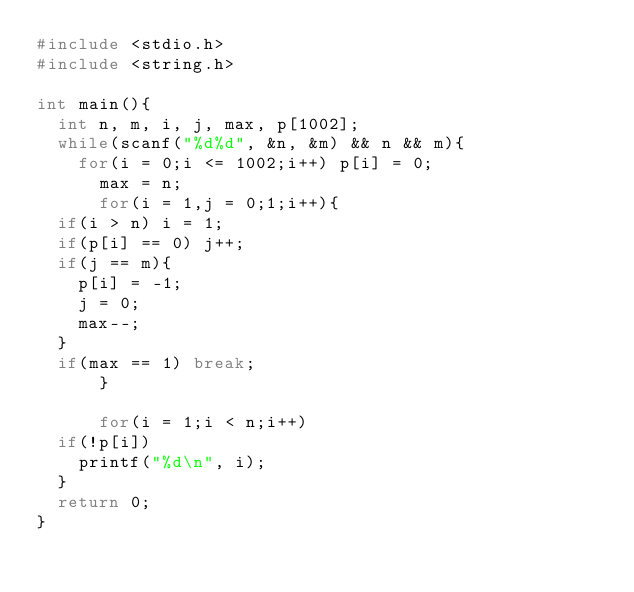<code> <loc_0><loc_0><loc_500><loc_500><_C_>#include <stdio.h>
#include <string.h>

int main(){
  int n, m, i, j, max, p[1002];
  while(scanf("%d%d", &n, &m) && n && m){
    for(i = 0;i <= 1002;i++) p[i] = 0;
      max = n;
      for(i = 1,j = 0;1;i++){
	if(i > n) i = 1;
	if(p[i] == 0) j++;
	if(j == m){
	  p[i] = -1;
	  j = 0;
	  max--;
	}
	if(max == 1) break;
      }

      for(i = 1;i < n;i++) 
	if(!p[i])
	  printf("%d\n", i);
  }
  return 0;
}</code> 